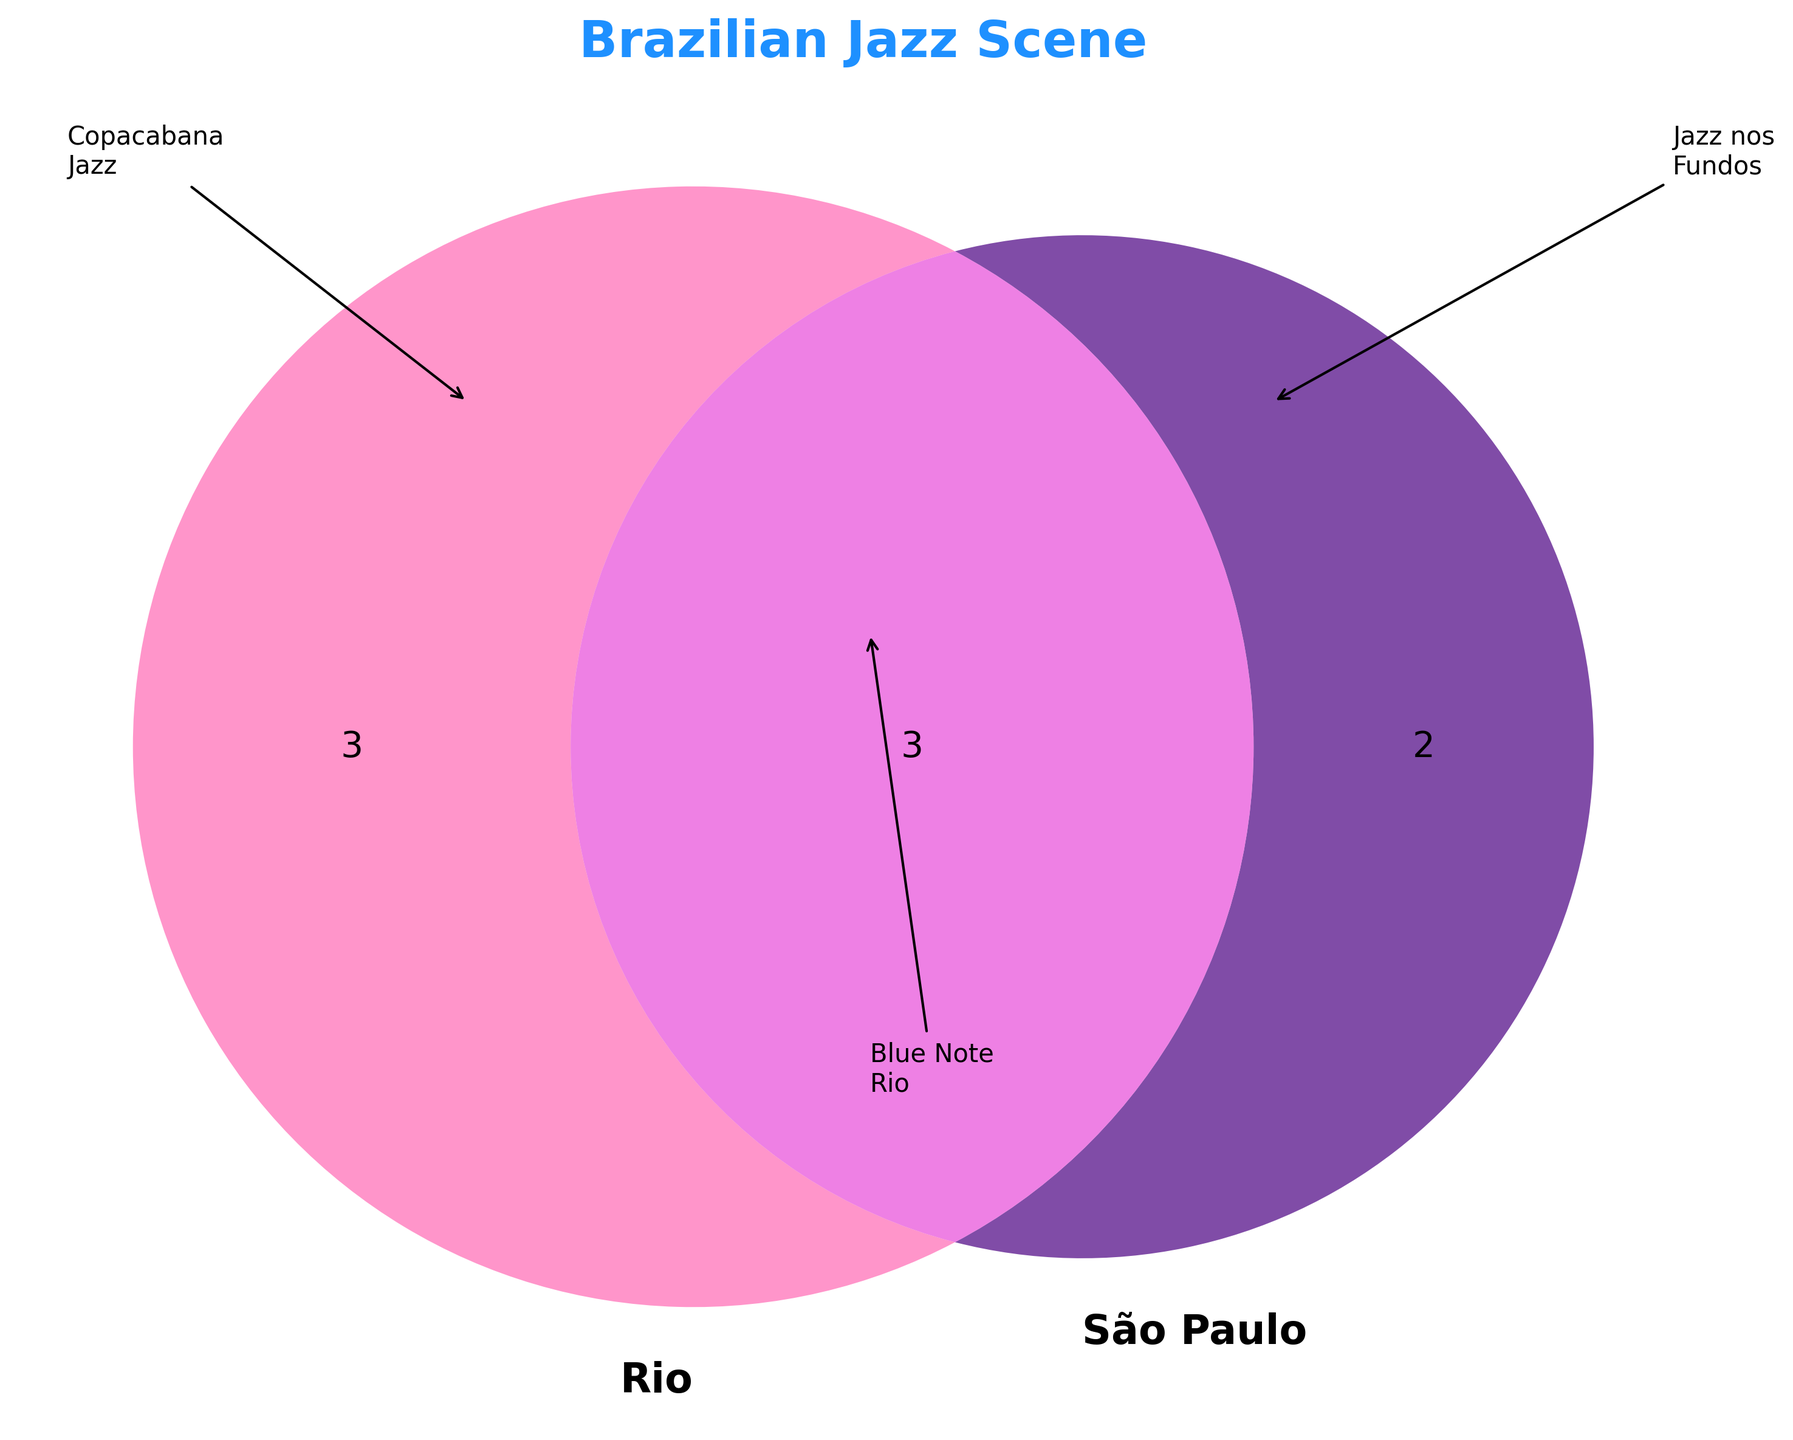What's the title of the figure? The title of the figure is displayed at the top and reads "Brazilian Jazz Scene".
Answer: Brazilian Jazz Scene How many jazz festivals are exclusively in Rio? The left circle of the Venn diagram represents Rio and contains segments for Rio-only festivals. By counting, there are three Rio-only festivals.
Answer: Three Which jazz event appears in both Rio and São Paulo? The overlapping area between the two circles shows events common to both Rio and São Paulo. Here, Blue Note Rio, SESC Jazz Festival, and Instrumental SESC Brasil Series are listed.
Answer: Blue Note Rio, SESC Jazz Festival, Instrumental SESC Brasil Series How many venues or festivals are shared by both cities? The overlapping section of the Venn diagram shows the number of events common to both cities. There are three such events.
Answer: Three Compare the number of exclusive Rio festivals to São Paulo venues. Which is greater? By comparing, Rio-only has three exclusive festivals, and São Paulo-only has two exclusive venues. Thus, Rio has more exclusive events.
Answer: Rio What's unique to the São Paulo venues section? The right circle represents São Paulo. Unique to São Paulo venues, we see Jazz nos Fundos and Bourbon Street Music Club.
Answer: Jazz nos Fundos, Bourbon Street Music Club What are the Rio exclusive events? The left circle shows events unique to Rio, excluding the overlapping part. They are Copacabana Jazz Festival, Bossa Nova Week, and Rio das Ostras Jazz & Blues Festival.
Answer: Copacabana Jazz Festival, Bossa Nova Week, Rio das Ostras Jazz & Blues Festival If total events shared in Rio and São Paulo are counted with exclusive ones, how many Rio events are there? Adding Rio-exclusive events (3) and shared events (3), the total number of Rio-related events is 3 + 3.
Answer: Six Identify a jazz event in Rio using an arrow annotation in the diagram. An arrow annotation points to an event labeled "Copacabana Jazz" within the Rio circle.
Answer: Copacabana Jazz In the figure, how is the São Paulo Jazz nos Fundos event highlighted? An arrow annotation points to Jazz nos Fundos in the São Paulo circle, making it easier to identify.
Answer: With an arrow annotation 